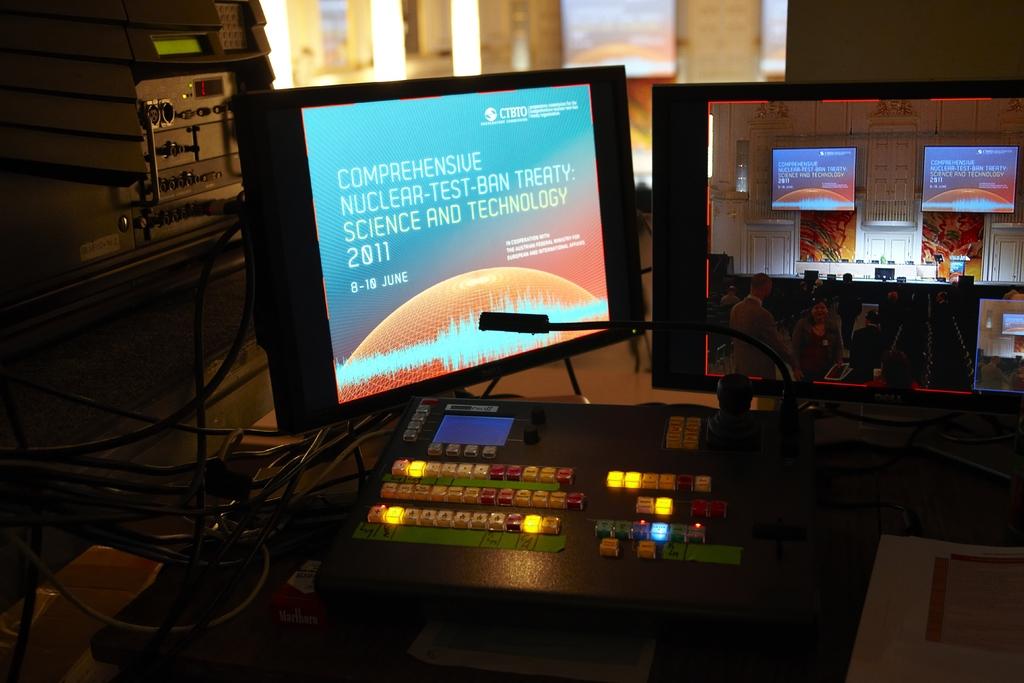Was this made in june?
Ensure brevity in your answer.  Yes. What does it say on this monitor?
Your answer should be very brief. Comprehensive nuclear-test-ban treaty: science and technology 2011. 